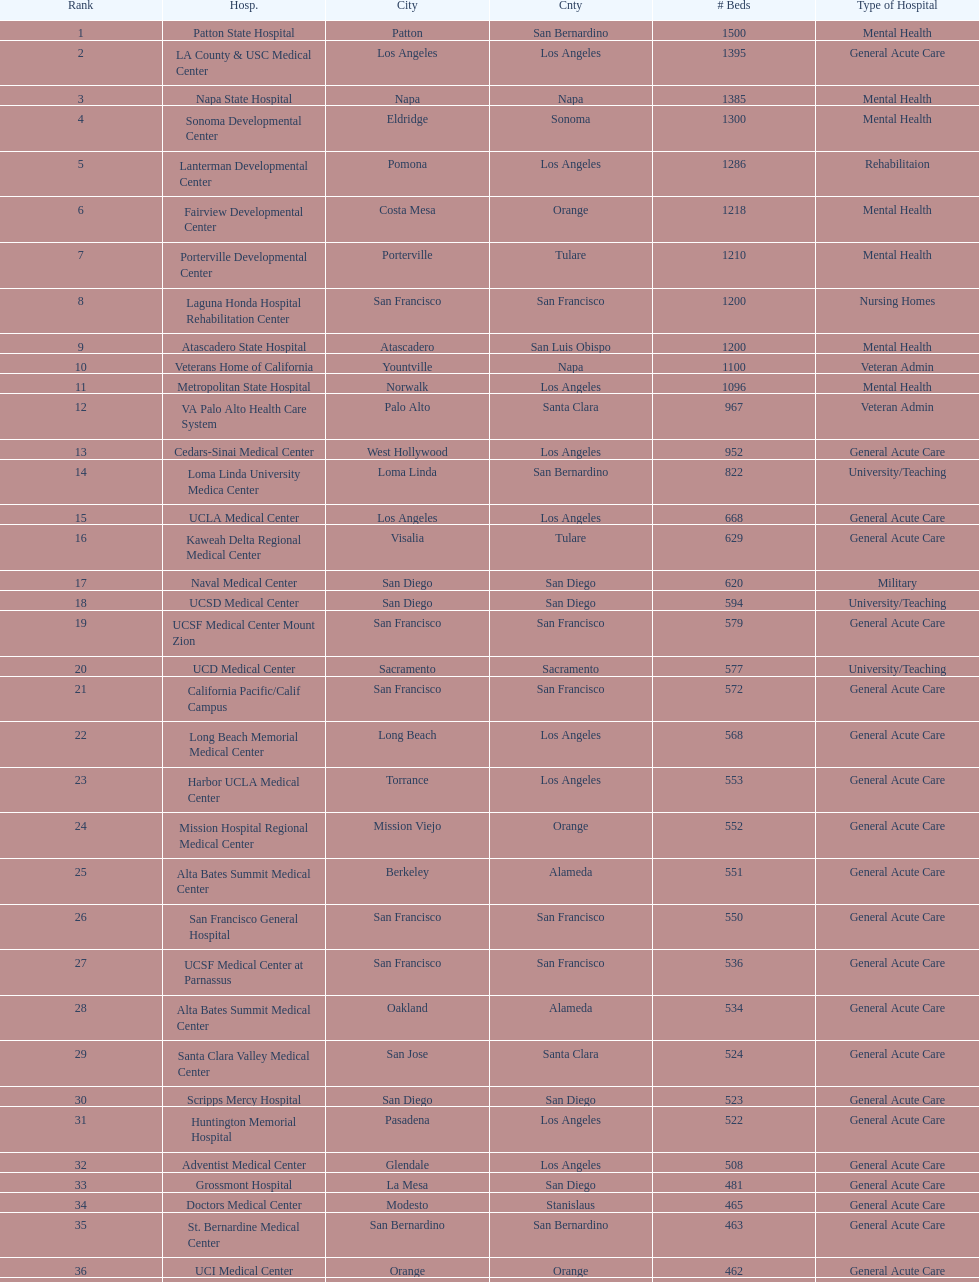Does patton state hospital have a higher capacity for mental health hospital beds compared to atascadero state hospital? Yes. 